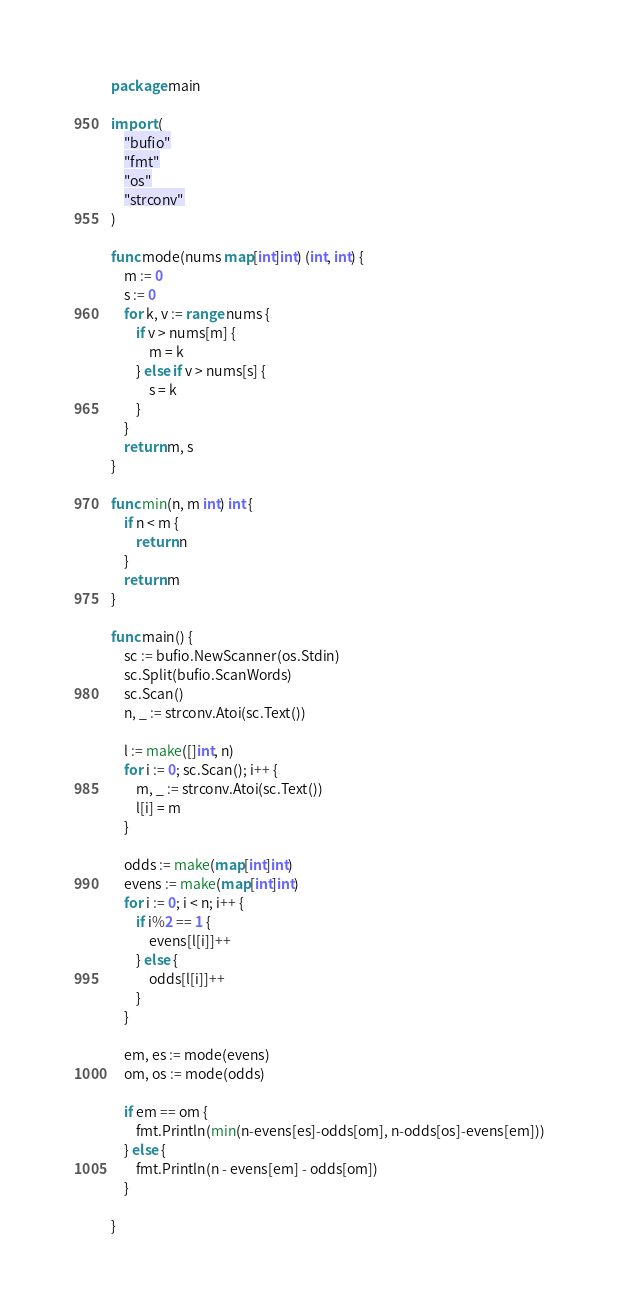<code> <loc_0><loc_0><loc_500><loc_500><_Go_>package main

import (
	"bufio"
	"fmt"
	"os"
	"strconv"
)

func mode(nums map[int]int) (int, int) {
	m := 0
	s := 0
	for k, v := range nums {
		if v > nums[m] {
			m = k
		} else if v > nums[s] {
			s = k
		}
	}
	return m, s
}

func min(n, m int) int {
	if n < m {
		return n
	}
	return m
}

func main() {
	sc := bufio.NewScanner(os.Stdin)
	sc.Split(bufio.ScanWords)
	sc.Scan()
	n, _ := strconv.Atoi(sc.Text())

	l := make([]int, n)
	for i := 0; sc.Scan(); i++ {
		m, _ := strconv.Atoi(sc.Text())
		l[i] = m
	}

	odds := make(map[int]int)
	evens := make(map[int]int)
	for i := 0; i < n; i++ {
		if i%2 == 1 {
			evens[l[i]]++
		} else {
			odds[l[i]]++
		}
	}

	em, es := mode(evens)
	om, os := mode(odds)

	if em == om {
		fmt.Println(min(n-evens[es]-odds[om], n-odds[os]-evens[em]))
	} else {
		fmt.Println(n - evens[em] - odds[om])
	}

}
</code> 